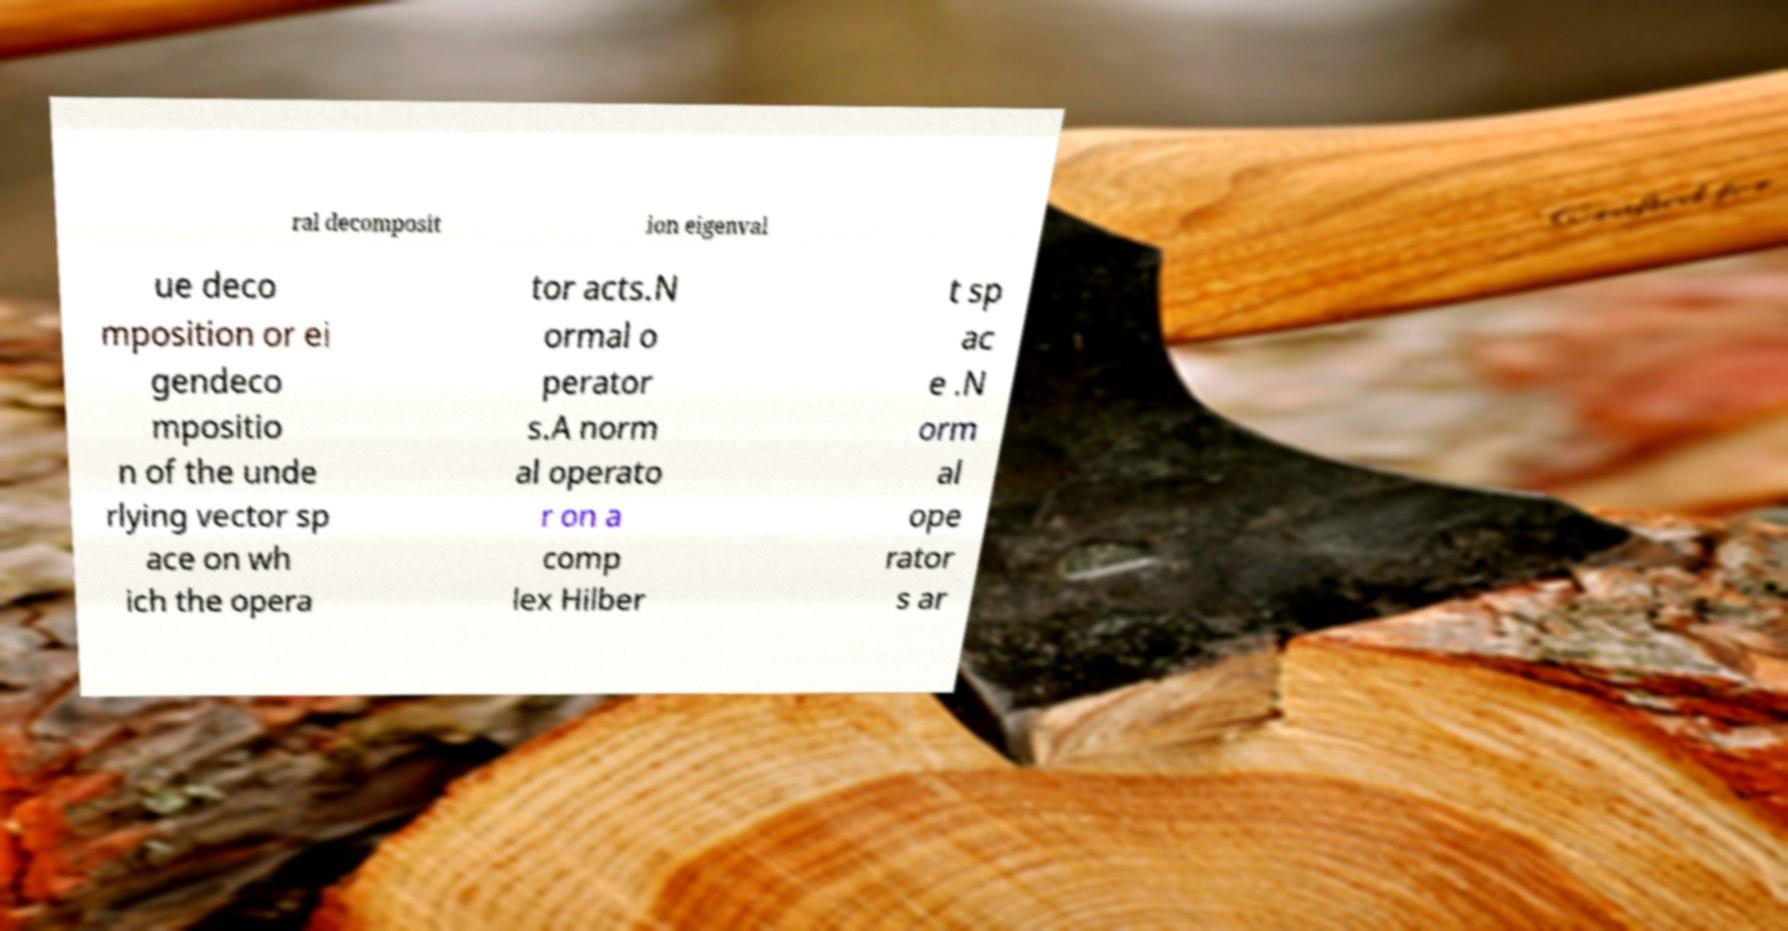Could you extract and type out the text from this image? ral decomposit ion eigenval ue deco mposition or ei gendeco mpositio n of the unde rlying vector sp ace on wh ich the opera tor acts.N ormal o perator s.A norm al operato r on a comp lex Hilber t sp ac e .N orm al ope rator s ar 